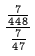Convert formula to latex. <formula><loc_0><loc_0><loc_500><loc_500>\frac { \frac { 7 } { 4 4 8 } } { \frac { 7 } { 4 7 } }</formula> 